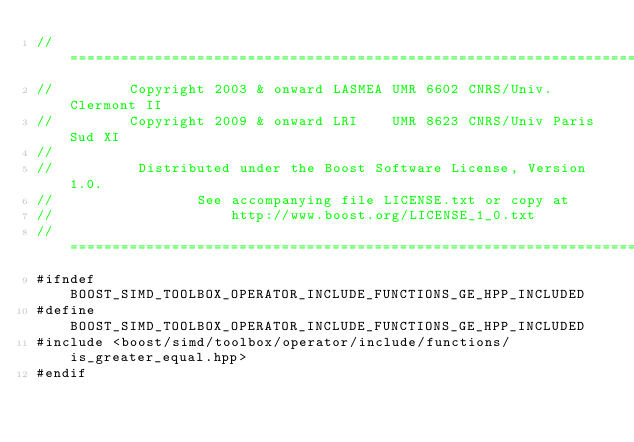Convert code to text. <code><loc_0><loc_0><loc_500><loc_500><_C++_>//==============================================================================
//         Copyright 2003 & onward LASMEA UMR 6602 CNRS/Univ. Clermont II
//         Copyright 2009 & onward LRI    UMR 8623 CNRS/Univ Paris Sud XI
//
//          Distributed under the Boost Software License, Version 1.0.
//                 See accompanying file LICENSE.txt or copy at
//                     http://www.boost.org/LICENSE_1_0.txt
//==============================================================================
#ifndef BOOST_SIMD_TOOLBOX_OPERATOR_INCLUDE_FUNCTIONS_GE_HPP_INCLUDED
#define BOOST_SIMD_TOOLBOX_OPERATOR_INCLUDE_FUNCTIONS_GE_HPP_INCLUDED
#include <boost/simd/toolbox/operator/include/functions/is_greater_equal.hpp>
#endif
</code> 